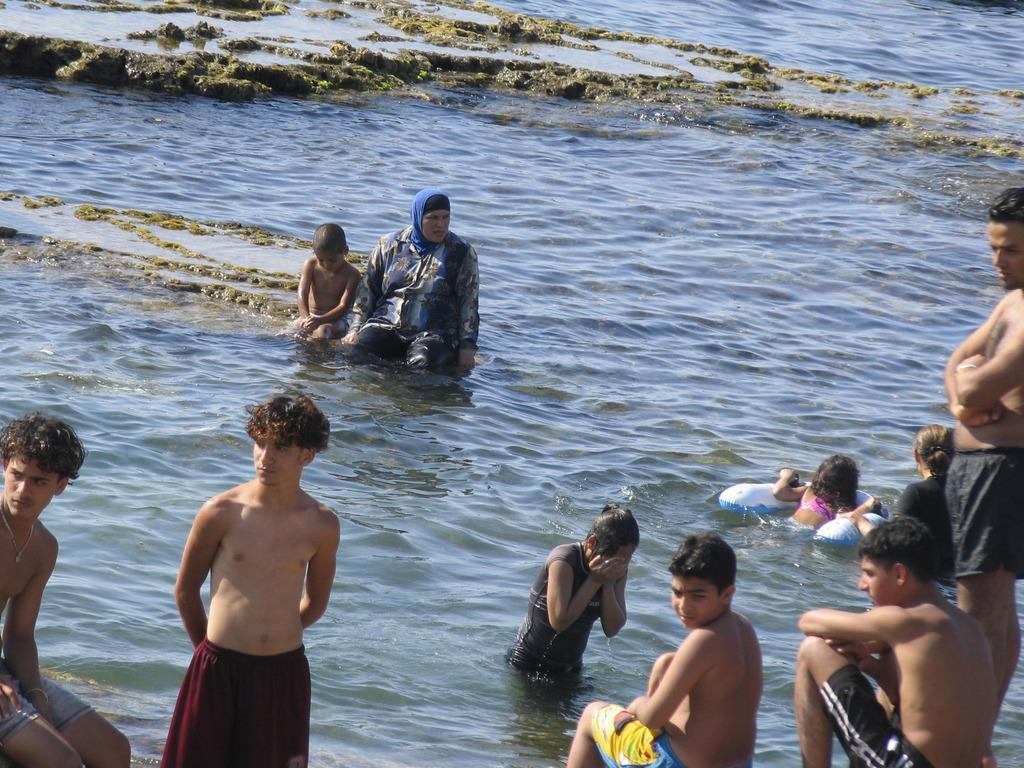Could you give a brief overview of what you see in this image? In this picture we can see a group of people where some are sitting and some are standing and in the background we can see water. 